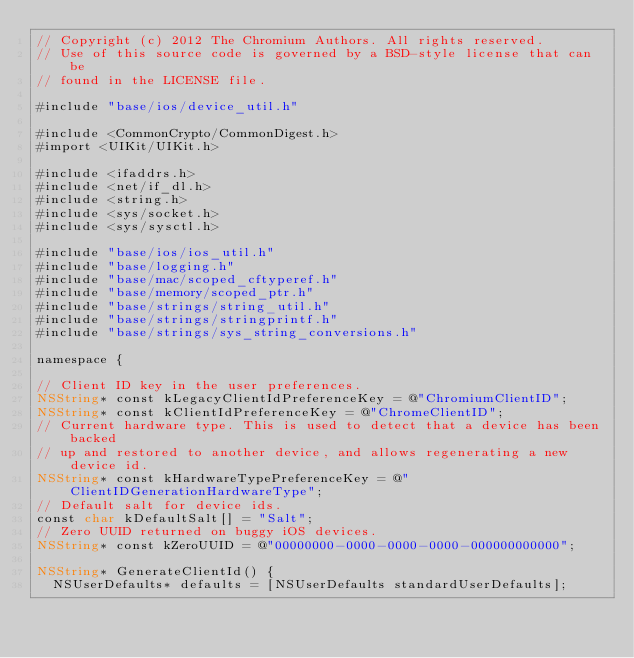Convert code to text. <code><loc_0><loc_0><loc_500><loc_500><_ObjectiveC_>// Copyright (c) 2012 The Chromium Authors. All rights reserved.
// Use of this source code is governed by a BSD-style license that can be
// found in the LICENSE file.

#include "base/ios/device_util.h"

#include <CommonCrypto/CommonDigest.h>
#import <UIKit/UIKit.h>

#include <ifaddrs.h>
#include <net/if_dl.h>
#include <string.h>
#include <sys/socket.h>
#include <sys/sysctl.h>

#include "base/ios/ios_util.h"
#include "base/logging.h"
#include "base/mac/scoped_cftyperef.h"
#include "base/memory/scoped_ptr.h"
#include "base/strings/string_util.h"
#include "base/strings/stringprintf.h"
#include "base/strings/sys_string_conversions.h"

namespace {

// Client ID key in the user preferences.
NSString* const kLegacyClientIdPreferenceKey = @"ChromiumClientID";
NSString* const kClientIdPreferenceKey = @"ChromeClientID";
// Current hardware type. This is used to detect that a device has been backed
// up and restored to another device, and allows regenerating a new device id.
NSString* const kHardwareTypePreferenceKey = @"ClientIDGenerationHardwareType";
// Default salt for device ids.
const char kDefaultSalt[] = "Salt";
// Zero UUID returned on buggy iOS devices.
NSString* const kZeroUUID = @"00000000-0000-0000-0000-000000000000";

NSString* GenerateClientId() {
  NSUserDefaults* defaults = [NSUserDefaults standardUserDefaults];
</code> 